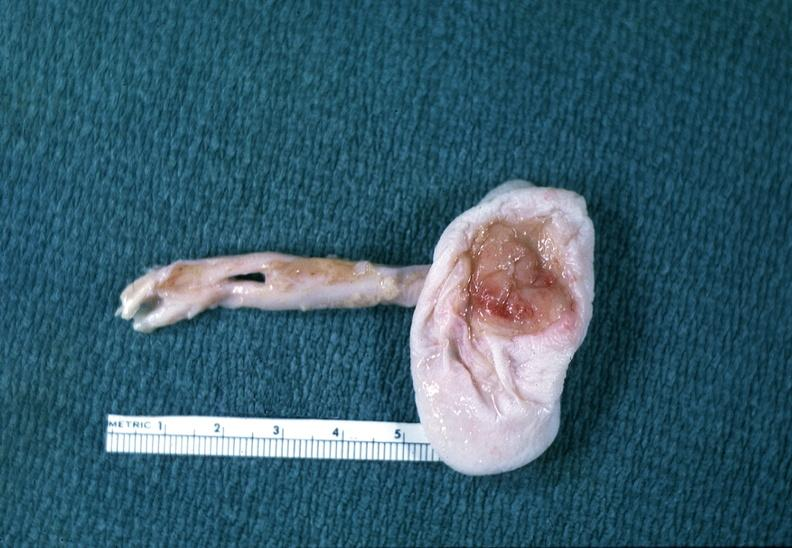what is present?
Answer the question using a single word or phrase. Nervous 